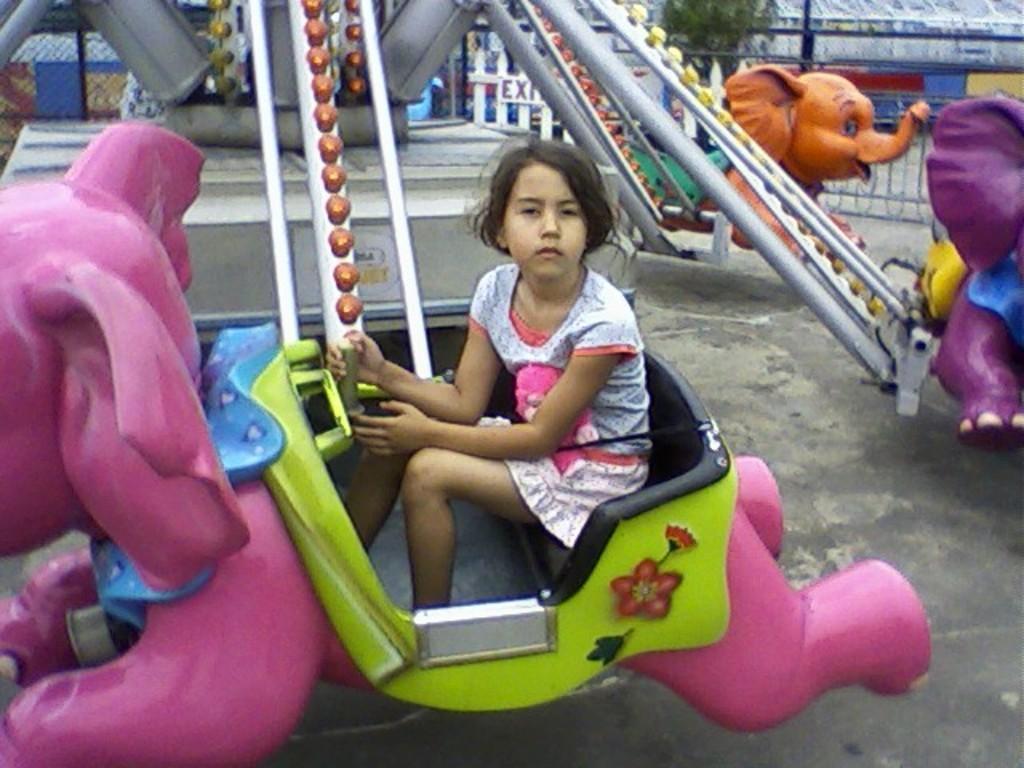How would you summarize this image in a sentence or two? This picture looks like a girl sitting in the amusement park ride and I can see a tree in the back and I can see metal fence and a board with some text. 